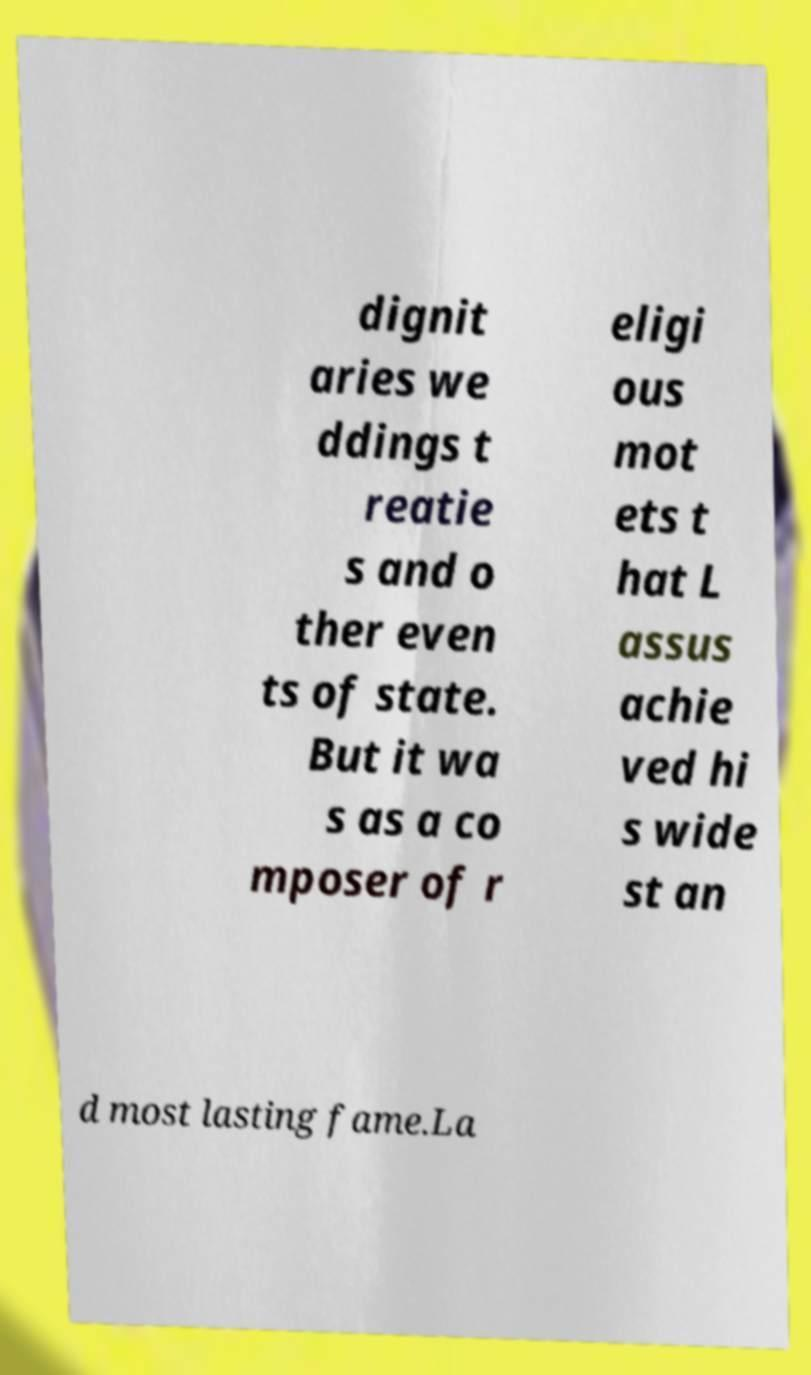Could you extract and type out the text from this image? dignit aries we ddings t reatie s and o ther even ts of state. But it wa s as a co mposer of r eligi ous mot ets t hat L assus achie ved hi s wide st an d most lasting fame.La 